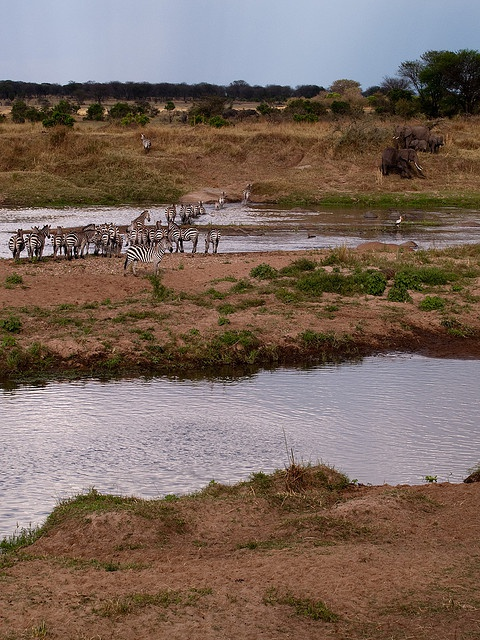Describe the objects in this image and their specific colors. I can see zebra in darkgray, black, gray, and maroon tones, zebra in darkgray, black, and gray tones, elephant in darkgray, black, maroon, and gray tones, zebra in darkgray, black, gray, and maroon tones, and elephant in darkgray, black, maroon, and brown tones in this image. 